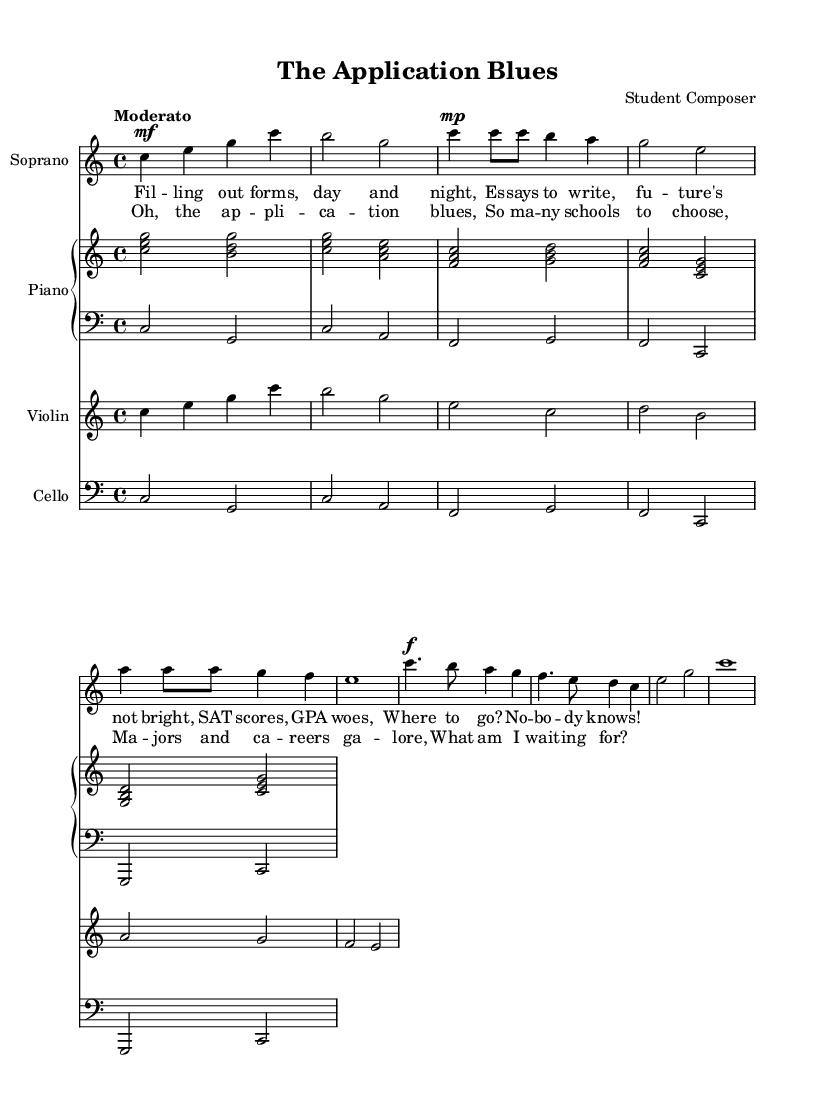What is the key signature of this music? The key signature is C major, which has no sharps or flats.
Answer: C major What is the time signature of this music? The time signature appears at the beginning of the score after the key signature, indicating that there are four beats in each measure.
Answer: 4/4 What is the tempo marking for this piece? The tempo marking is indicated above the first system of the sheet music and suggests a moderate speed for the performance.
Answer: Moderato How many measures are there in the introduction section? By counting the measures in the introductory section, we find there are four measures in total.
Answer: 4 Which instruments are included in this opera piece? The score lists specific staves for each instrument, including soprano, piano (upper and lower), violin, and cello, making up the orchestration.
Answer: Soprano, piano, violin, cello What is the main theme of the chorus lyrics? The chorus conveys emotions about the overwhelming options and anxiety related to college applications and career decisions, highlighting the struggle faced by students.
Answer: Application blues Which vocal part has the highest pitch in this score? By analyzing the written notes for each vocal part, it is clear that the soprano part generally has the highest pitch range compared to other instruments like violin and cello.
Answer: Soprano 